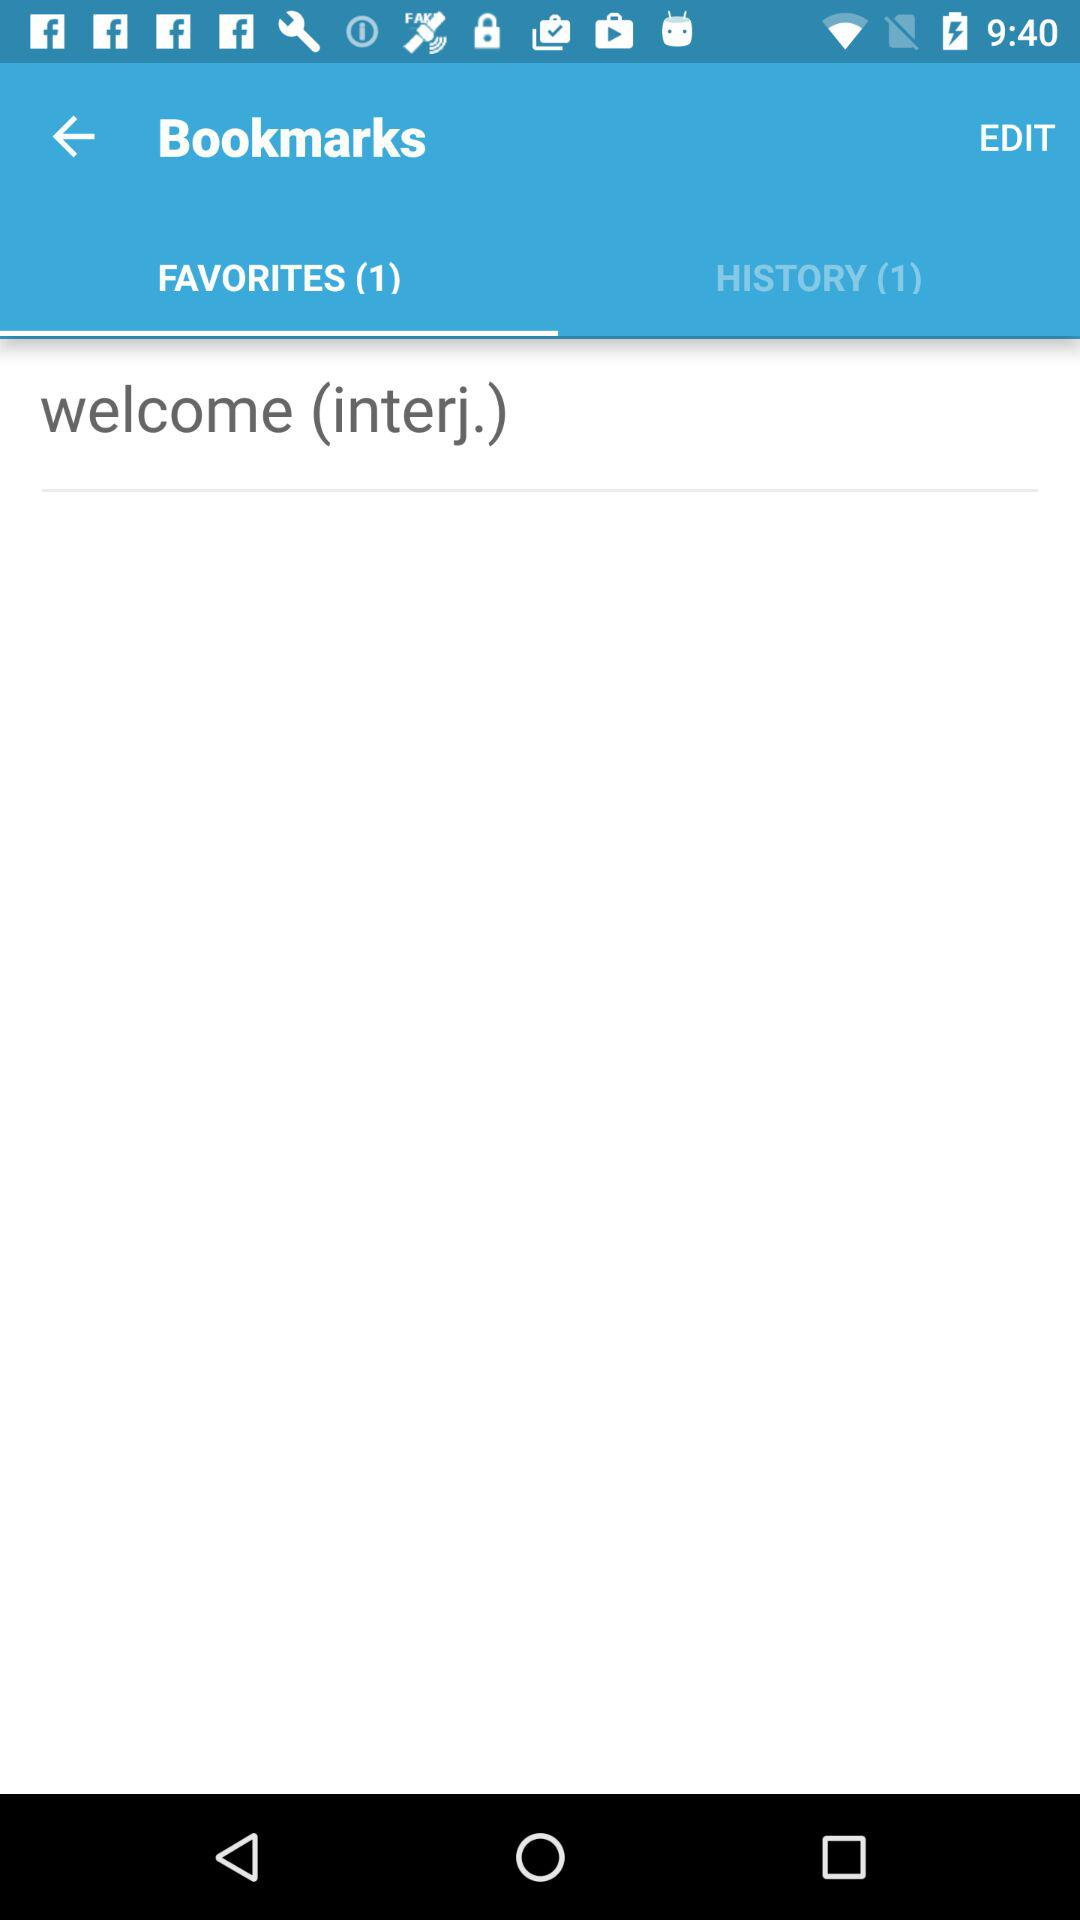Which tab is selected? The selected tab is "FAVORITES". 